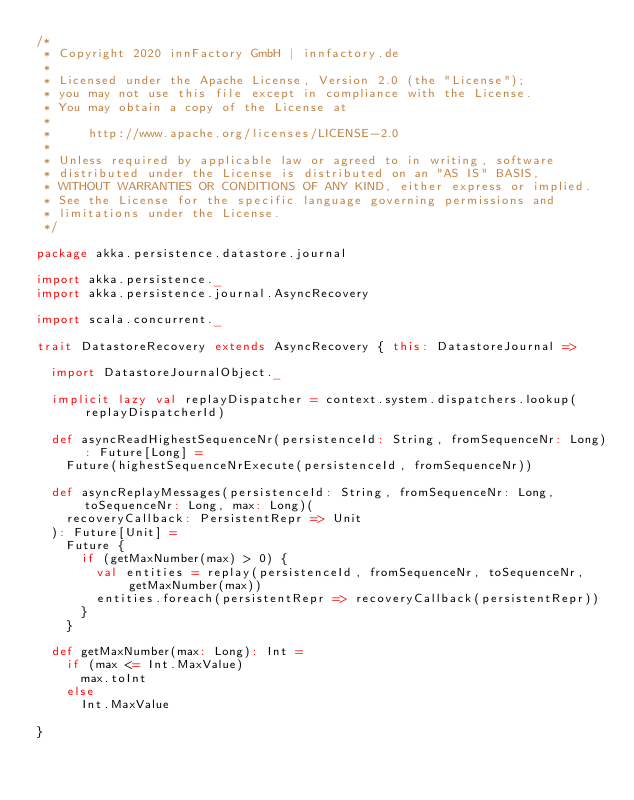Convert code to text. <code><loc_0><loc_0><loc_500><loc_500><_Scala_>/*
 * Copyright 2020 innFactory GmbH | innfactory.de
 *
 * Licensed under the Apache License, Version 2.0 (the "License");
 * you may not use this file except in compliance with the License.
 * You may obtain a copy of the License at
 *
 *     http://www.apache.org/licenses/LICENSE-2.0
 *
 * Unless required by applicable law or agreed to in writing, software
 * distributed under the License is distributed on an "AS IS" BASIS,
 * WITHOUT WARRANTIES OR CONDITIONS OF ANY KIND, either express or implied.
 * See the License for the specific language governing permissions and
 * limitations under the License.
 */

package akka.persistence.datastore.journal

import akka.persistence._
import akka.persistence.journal.AsyncRecovery

import scala.concurrent._

trait DatastoreRecovery extends AsyncRecovery { this: DatastoreJournal =>

  import DatastoreJournalObject._

  implicit lazy val replayDispatcher = context.system.dispatchers.lookup(replayDispatcherId)

  def asyncReadHighestSequenceNr(persistenceId: String, fromSequenceNr: Long): Future[Long] =
    Future(highestSequenceNrExecute(persistenceId, fromSequenceNr))

  def asyncReplayMessages(persistenceId: String, fromSequenceNr: Long, toSequenceNr: Long, max: Long)(
    recoveryCallback: PersistentRepr => Unit
  ): Future[Unit] =
    Future {
      if (getMaxNumber(max) > 0) {
        val entities = replay(persistenceId, fromSequenceNr, toSequenceNr, getMaxNumber(max))
        entities.foreach(persistentRepr => recoveryCallback(persistentRepr))
      }
    }

  def getMaxNumber(max: Long): Int =
    if (max <= Int.MaxValue)
      max.toInt
    else
      Int.MaxValue

}
</code> 